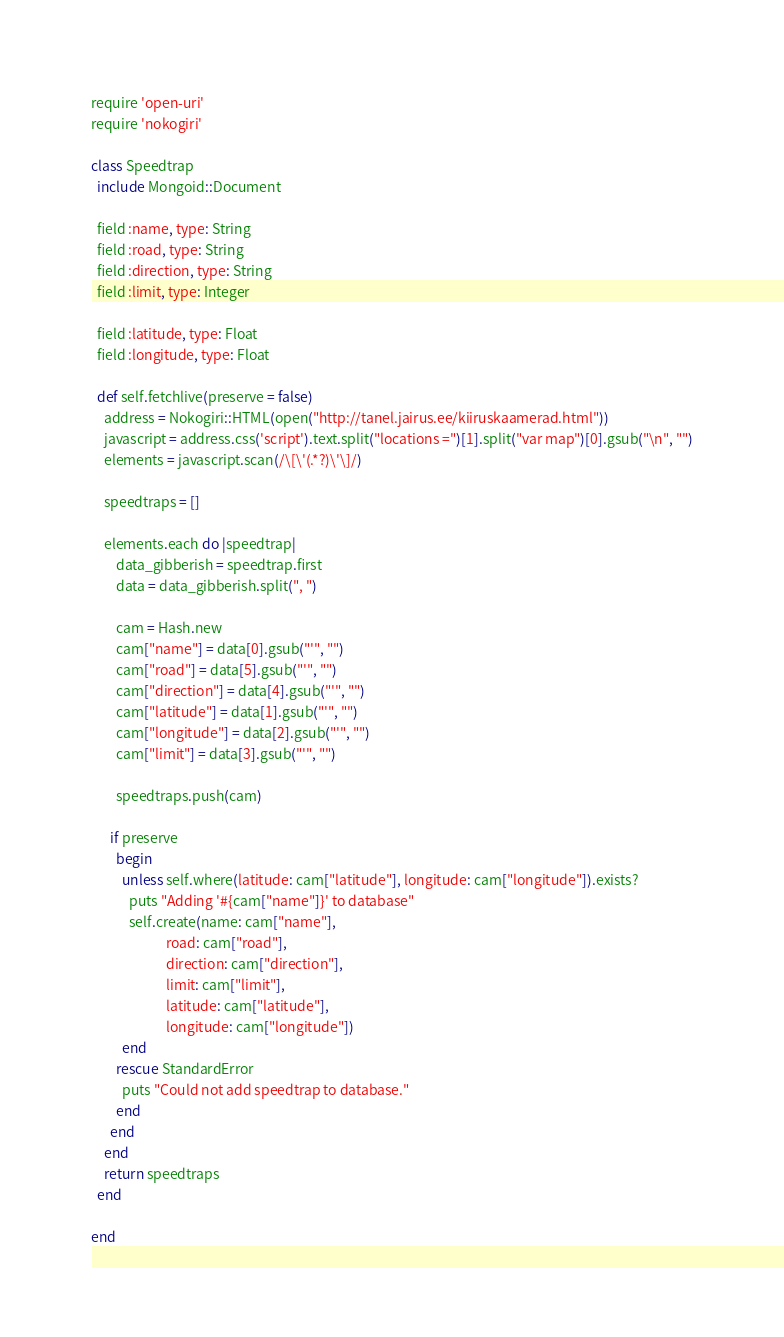<code> <loc_0><loc_0><loc_500><loc_500><_Ruby_>require 'open-uri'
require 'nokogiri'

class Speedtrap
  include Mongoid::Document

  field :name, type: String
  field :road, type: String
  field :direction, type: String
  field :limit, type: Integer

  field :latitude, type: Float
  field :longitude, type: Float

  def self.fetchlive(preserve = false)
  	address = Nokogiri::HTML(open("http://tanel.jairus.ee/kiiruskaamerad.html"))
  	javascript = address.css('script').text.split("locations =")[1].split("var map")[0].gsub("\n", "")
  	elements = javascript.scan(/\[\'(.*?)\'\]/)

  	speedtraps = []

  	elements.each do |speedtrap|
  		data_gibberish = speedtrap.first
  		data = data_gibberish.split(", ")

  		cam = Hash.new
  		cam["name"] = data[0].gsub("'", "")
  		cam["road"] = data[5].gsub("'", "")
  		cam["direction"] = data[4].gsub("'", "")
  		cam["latitude"] = data[1].gsub("'", "")
  		cam["longitude"] = data[2].gsub("'", "")
  		cam["limit"] = data[3].gsub("'", "")

  		speedtraps.push(cam)

      if preserve
        begin
          unless self.where(latitude: cam["latitude"], longitude: cam["longitude"]).exists?
            puts "Adding '#{cam["name"]}' to database"
            self.create(name: cam["name"],
                        road: cam["road"],
                        direction: cam["direction"],
                        limit: cam["limit"],
                        latitude: cam["latitude"],
                        longitude: cam["longitude"])
          end
        rescue StandardError
          puts "Could not add speedtrap to database."
        end
      end
  	end
  	return speedtraps
  end

end
</code> 